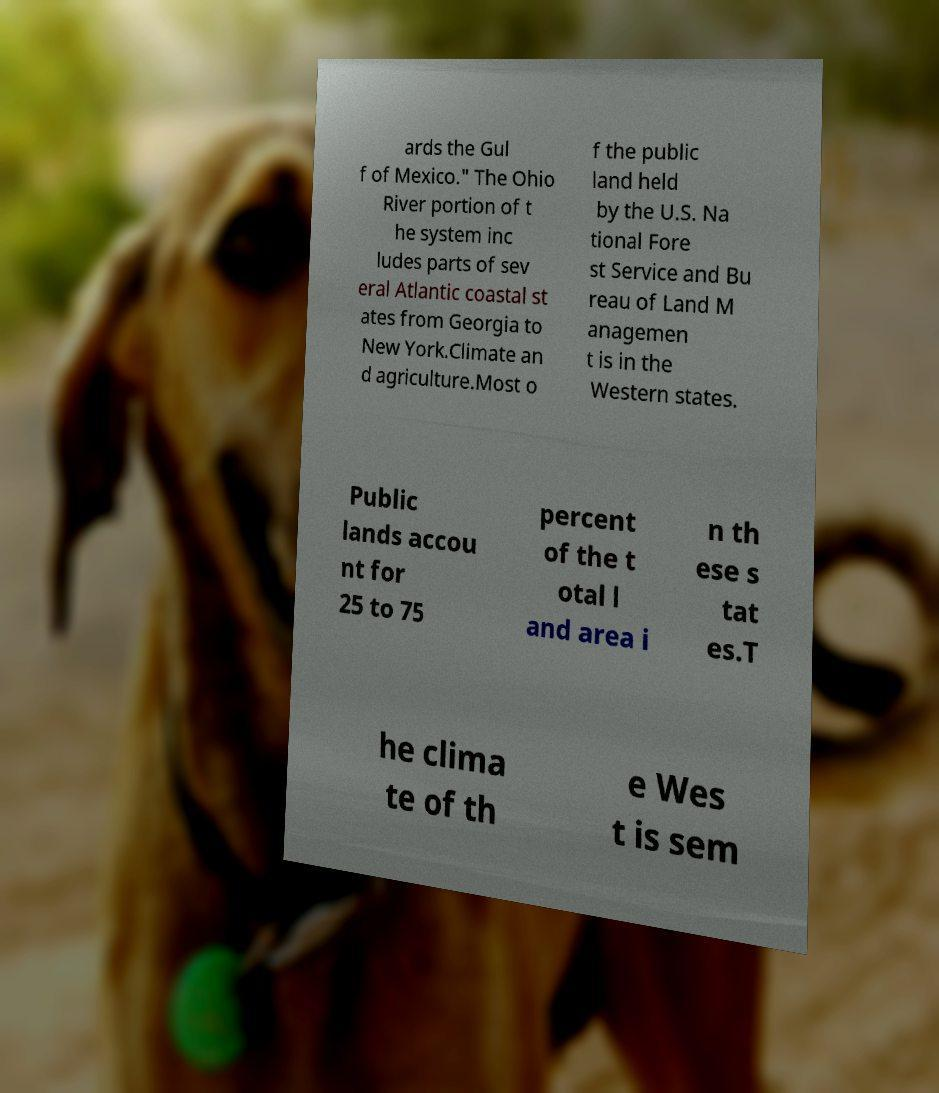Could you assist in decoding the text presented in this image and type it out clearly? ards the Gul f of Mexico." The Ohio River portion of t he system inc ludes parts of sev eral Atlantic coastal st ates from Georgia to New York.Climate an d agriculture.Most o f the public land held by the U.S. Na tional Fore st Service and Bu reau of Land M anagemen t is in the Western states. Public lands accou nt for 25 to 75 percent of the t otal l and area i n th ese s tat es.T he clima te of th e Wes t is sem 